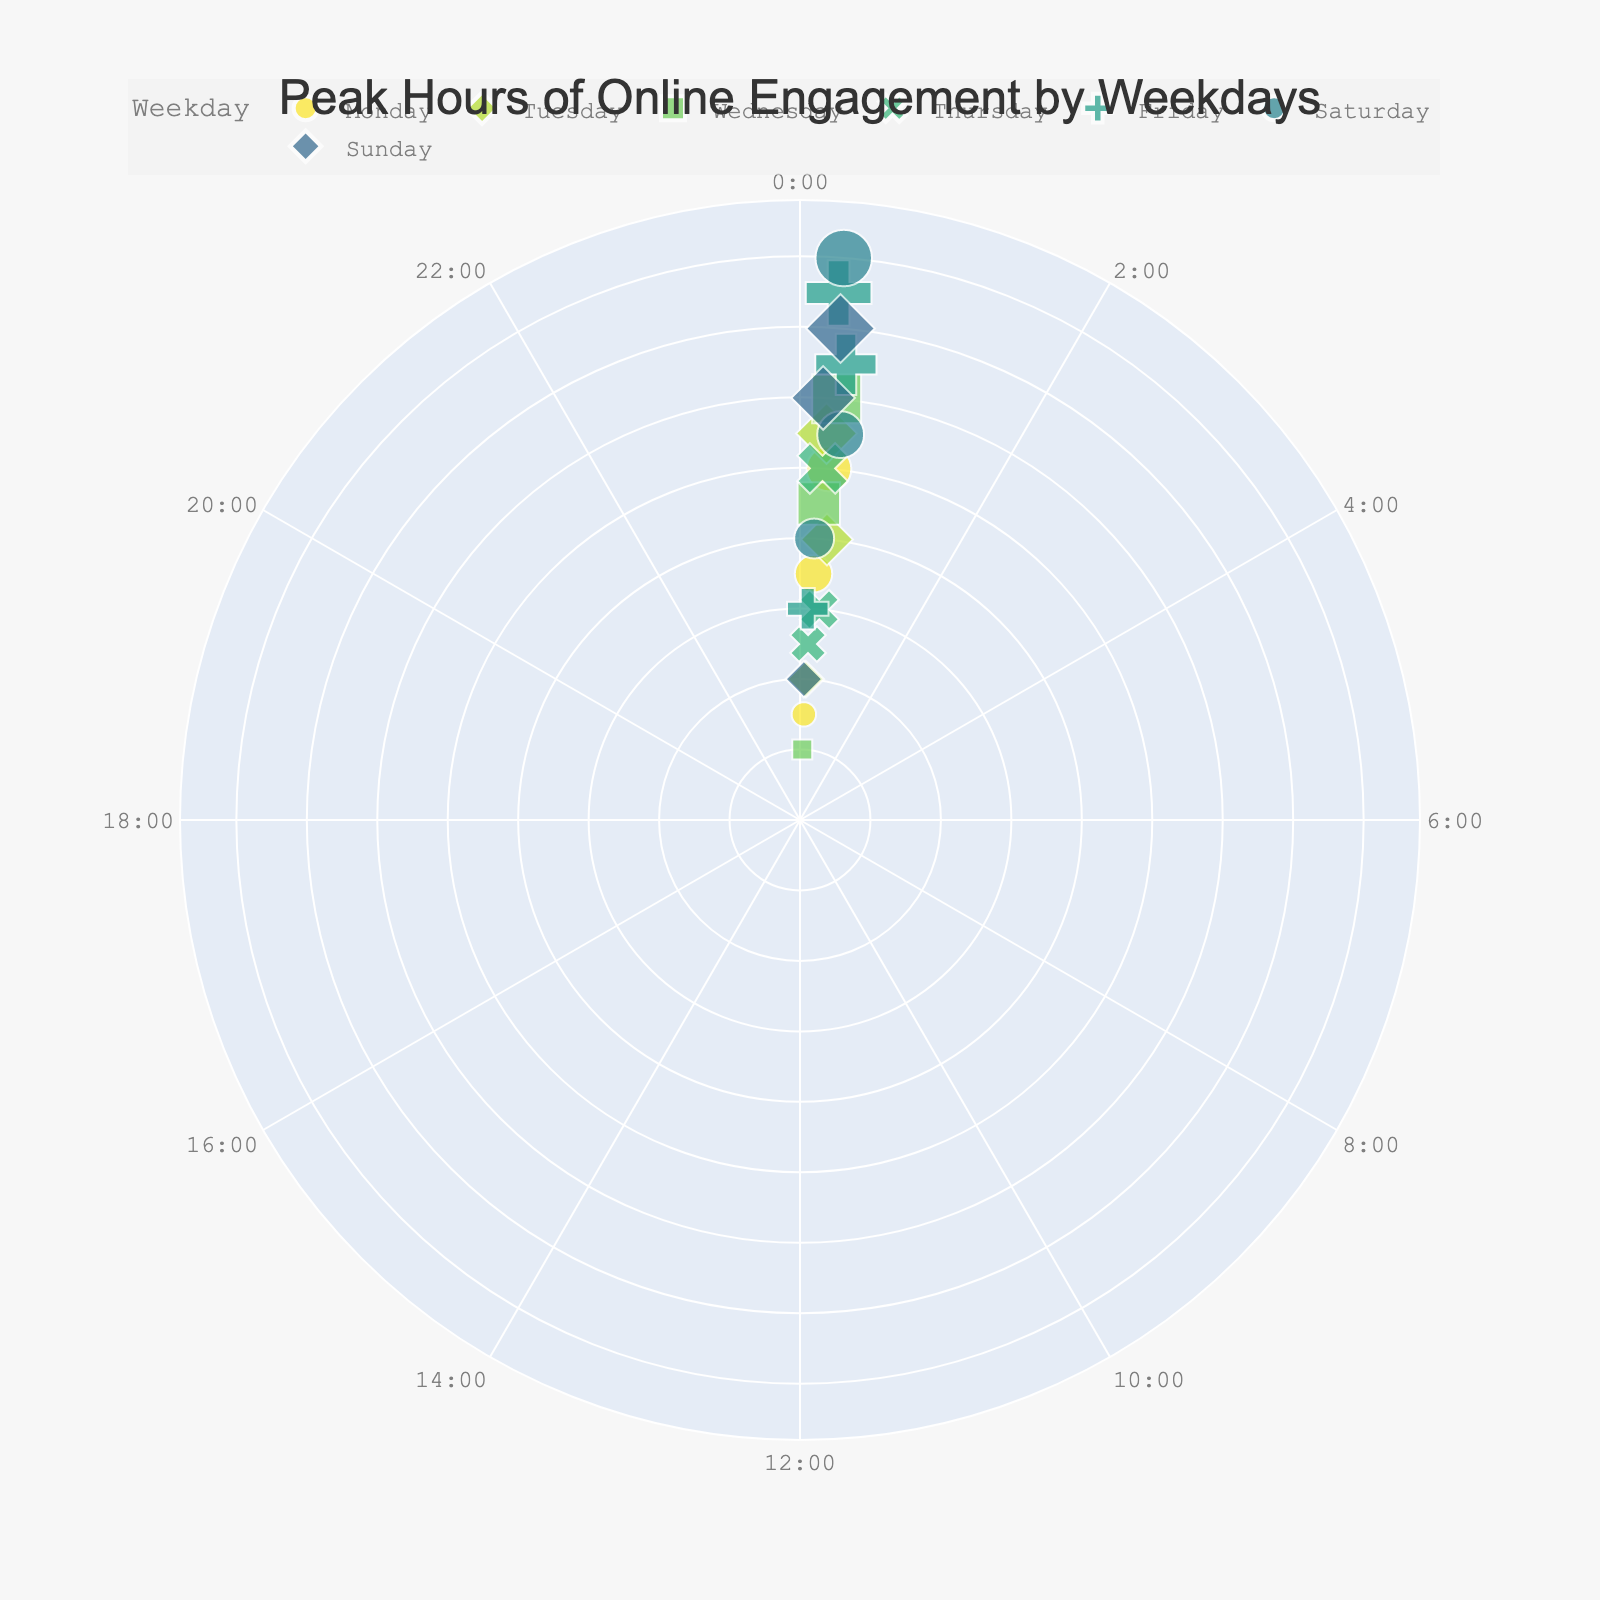What is the maximum engagement value displayed in the chart? Locate the radial axis to find the highest value. The maximum engagement value shown on the radial axis is 80.
Answer: 80 On which day of the week does the peak engagement occur? Check for the highest engagement point on the figure and note the corresponding weekday associated with this point. The highest engagement of 80 is on Saturday.
Answer: Saturday What are the peak hours of engagement on Friday? Inspect the data points associated with Friday and list the hours with the highest engagement values. The peak hours for Friday with significant engagements are 8:00, 16:00, and 22:00.
Answer: 8:00, 16:00, 22:00 What is the lowest engagement value, and on which day does it occur? Identify the smallest engagement value on the radial axis and check the corresponding weekday for that point. The lowest engagement value is 10, which occurs on Wednesday.
Answer: 10, Wednesday Which weekday has the highest concentration of posts with over 50 engagements? Identify the data points with engagements over 50, and count how many such points each weekday has. Saturday has the highest concentration with two points having engagements over 50.
Answer: Saturday How does the engagement level at 18:00 on Monday compare to the engagement level at the same time on Sunday? Compare the engagement values of the specific hour (18:00) for both Monday and Sunday. Engagement at 18:00 on Monday is 50 and on Sunday it is 70.
Answer: Sunday's engagement is higher at 18:00 For which weekdays are the engagement levels mostly above 30? Determine which days have the majority of data points (at least 3) above the engagement level of 30. Wednesday, Friday, Saturday, and Sunday mostly have engagement levels above 30.
Answer: Wednesday, Friday, Saturday, Sunday What is the average engagement level for posts made at noon (12:00) on different weekdays? Take the engagement values at 12:00 on Monday and Sunday, sum them up, and divide by the count of those days. Engagements at 12:00 are 35 and 60 respectively, average = (35 + 60) / 2 = 47.5.
Answer: 47.5 At what hour and weekday is the engagement level exactly 40? Identify the data point where engagement equals 40, and note the corresponding hour and weekday. Engagement of 40 occurs on Tuesday at 21:00 and Saturday at 11:00.
Answer: Tuesday 21:00, Saturday 11:00 